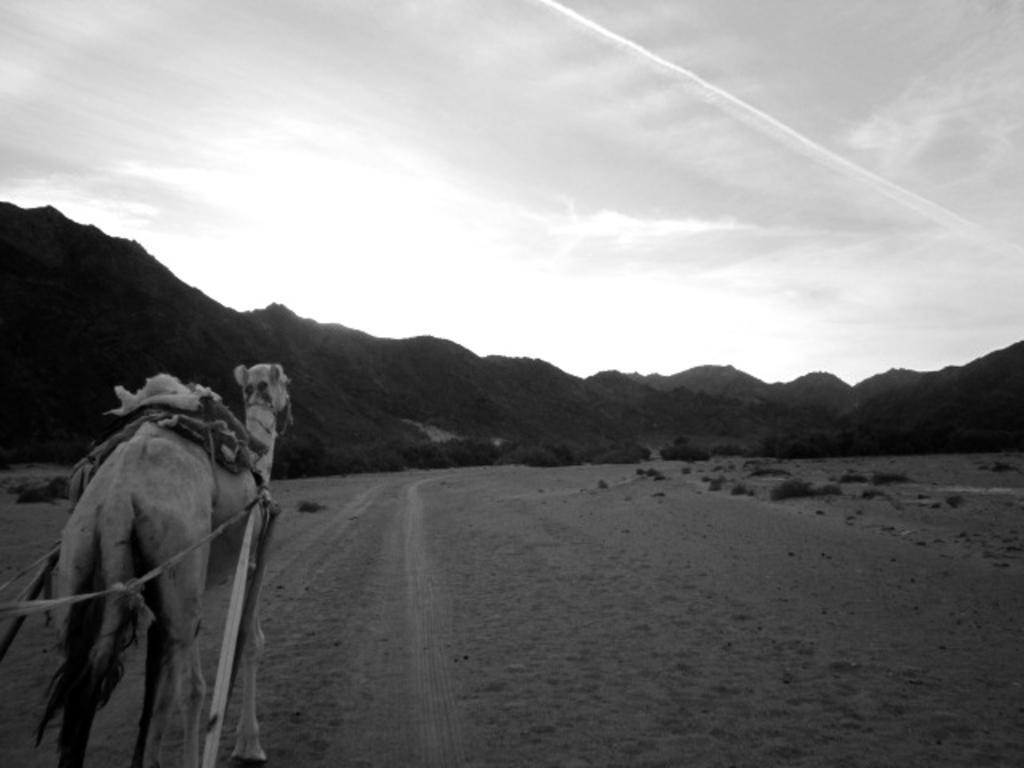In one or two sentences, can you explain what this image depicts? In the image I can see a camel on the ground. On the camel I can see some objects and tied with ropes. In the background I can see mountains, the sky and some other objects. This picture is black and white in color. 